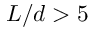<formula> <loc_0><loc_0><loc_500><loc_500>L / d > 5</formula> 